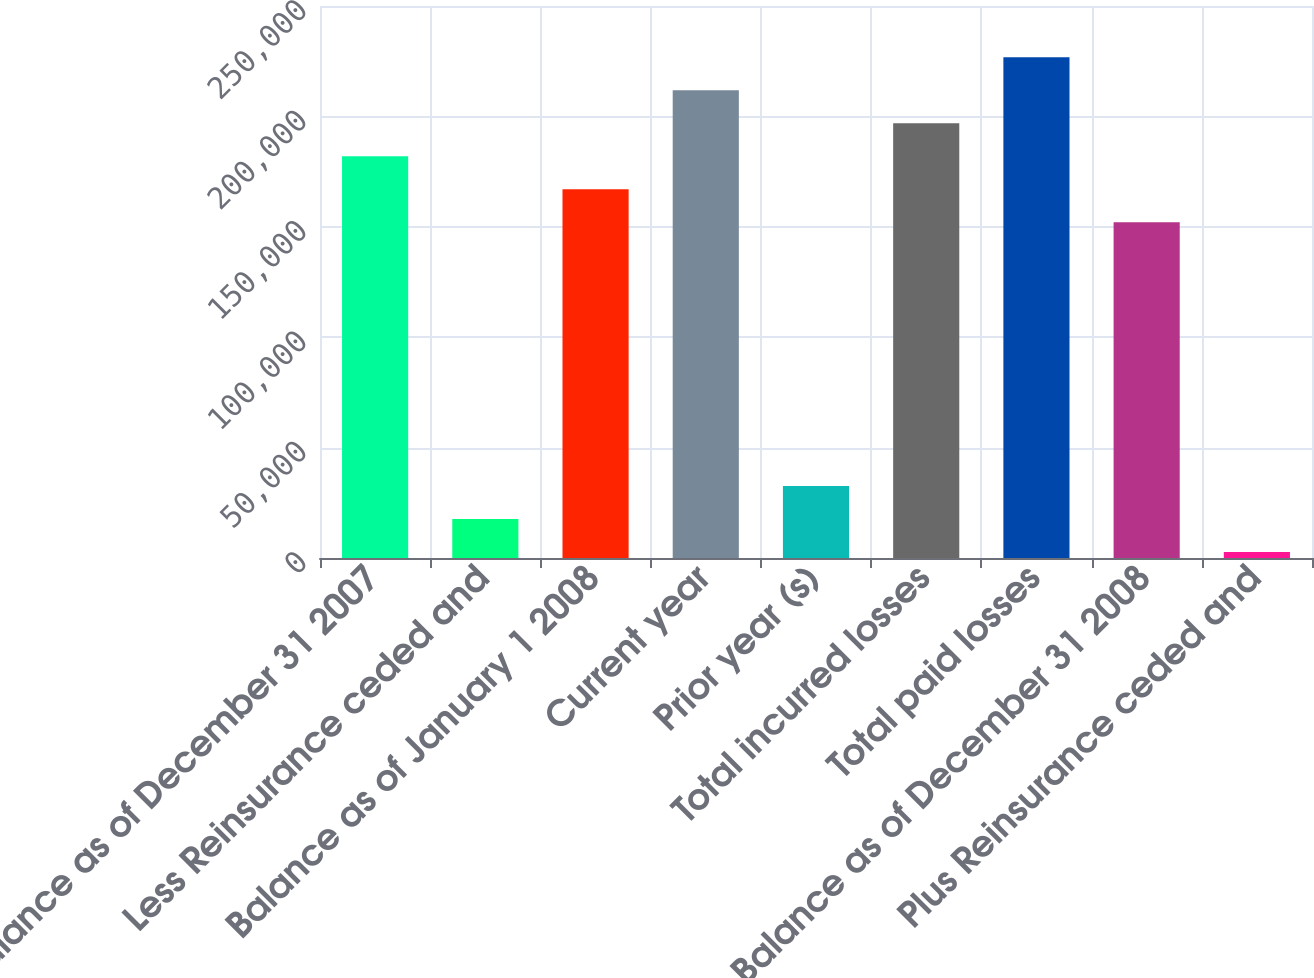Convert chart to OTSL. <chart><loc_0><loc_0><loc_500><loc_500><bar_chart><fcel>Balance as of December 31 2007<fcel>Less Reinsurance ceded and<fcel>Balance as of January 1 2008<fcel>Current year<fcel>Prior year (s)<fcel>Total incurred losses<fcel>Total paid losses<fcel>Balance as of December 31 2008<fcel>Plus Reinsurance ceded and<nl><fcel>181984<fcel>17702.7<fcel>167050<fcel>211854<fcel>32637.4<fcel>196919<fcel>226788<fcel>152115<fcel>2768<nl></chart> 